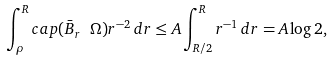Convert formula to latex. <formula><loc_0><loc_0><loc_500><loc_500>\int _ { \rho } ^ { R } c a p ( \bar { B } _ { r } \ \Omega ) r ^ { - 2 } \, d r \leq A \int _ { R / 2 } ^ { R } r ^ { - 1 } \, d r = A \log 2 ,</formula> 